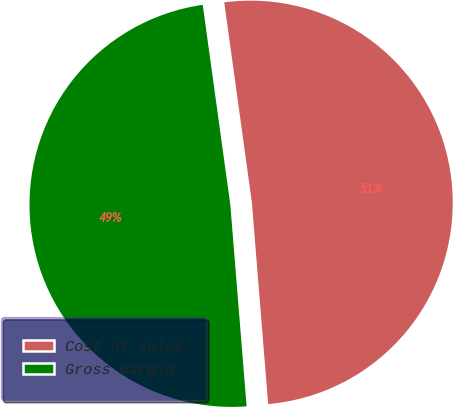<chart> <loc_0><loc_0><loc_500><loc_500><pie_chart><fcel>Cost of sales<fcel>Gross margin<nl><fcel>50.9%<fcel>49.1%<nl></chart> 